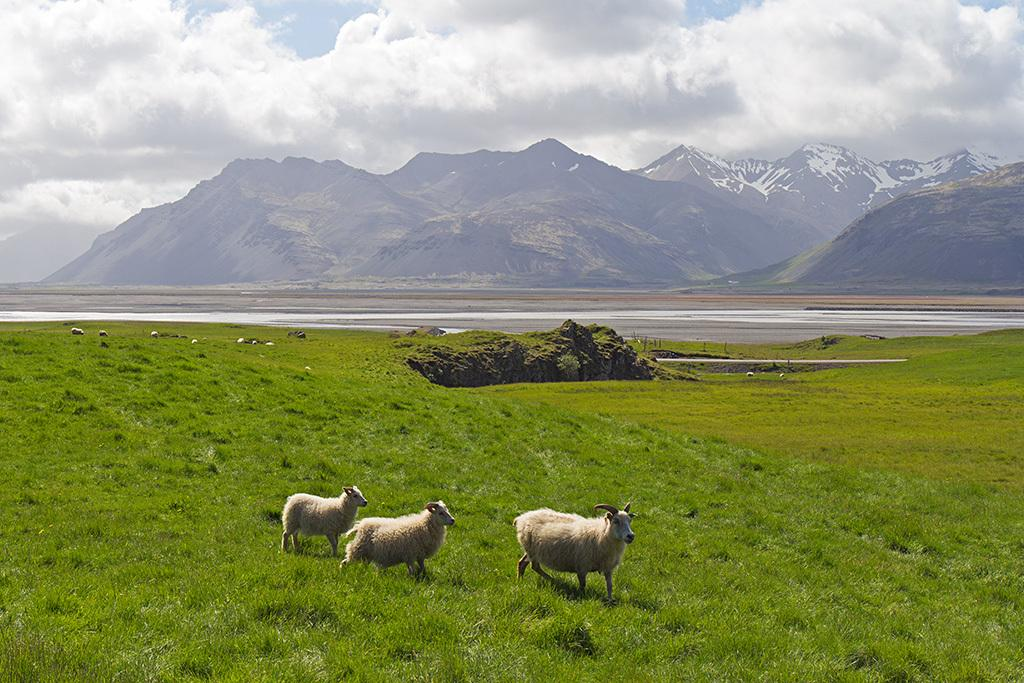What type of living organisms can be seen in the image? There are animals in the image. What is at the bottom of the image? There is grass at the bottom of the image. What can be seen in the background of the image? There are trees and the sky visible in the background of the image. What type of apparel is the animal wearing in the image? There is no apparel visible on the animals in the image. What is the animal reading in the image? There is no reading material or activity depicted in the image. 